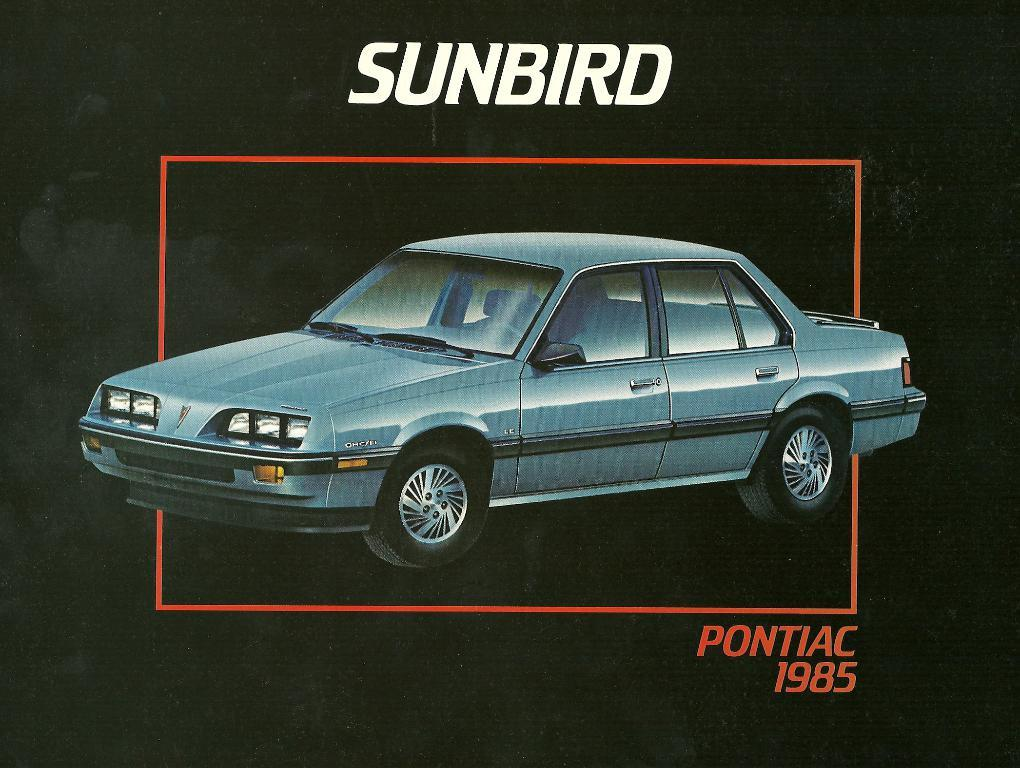What is the main subject in the middle of the image? There is a car in the middle of the image. What type of information is written at the top of the image? There is text written at the top of the image. What type of information is written at the bottom of the image? There is text written at the bottom of the image. What type of attraction can be seen in the image? There is no attraction present in the image; it features a car and text. What type of prose is written in the image? There is no prose present in the image; it features text, but we cannot determine its literary form from the image alone. 